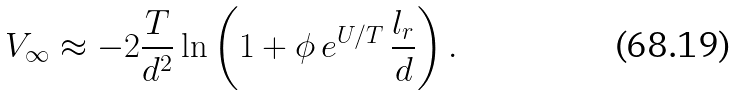Convert formula to latex. <formula><loc_0><loc_0><loc_500><loc_500>V _ { \infty } \approx - 2 \frac { T } { d ^ { 2 } } \ln \left ( 1 + \phi \, e ^ { U / T } \, \frac { l _ { r } } { d } \right ) .</formula> 